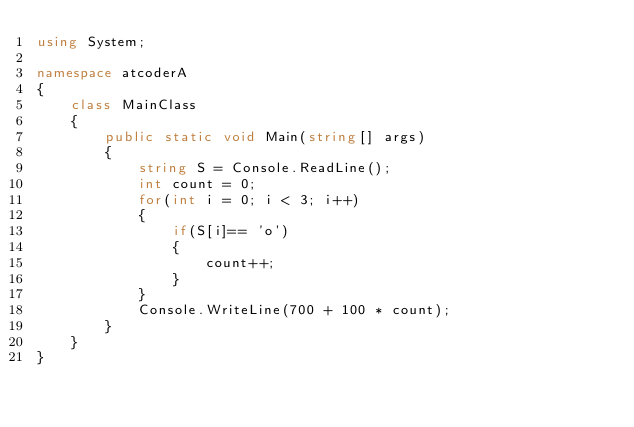Convert code to text. <code><loc_0><loc_0><loc_500><loc_500><_C#_>using System;

namespace atcoderA
{
    class MainClass
    {
        public static void Main(string[] args)
        {
            string S = Console.ReadLine();
            int count = 0;
            for(int i = 0; i < 3; i++)
            {
                if(S[i]== 'o')
                {
                    count++;
                }
            }
            Console.WriteLine(700 + 100 * count);
        }
    }
}</code> 